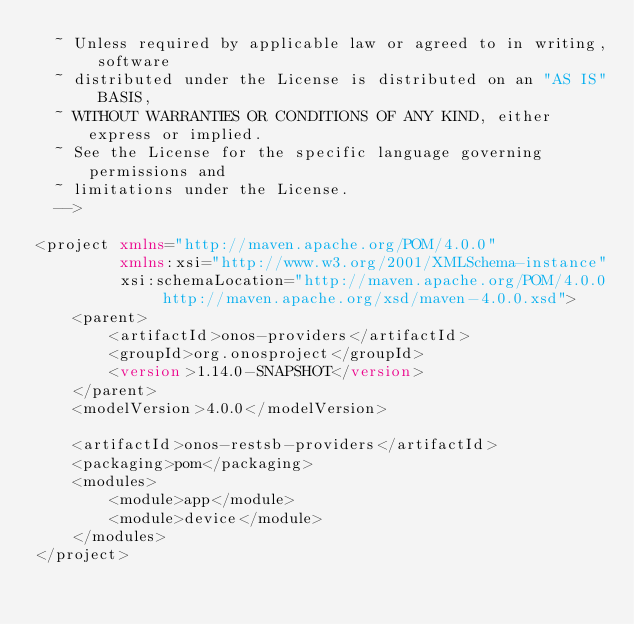<code> <loc_0><loc_0><loc_500><loc_500><_XML_>  ~ Unless required by applicable law or agreed to in writing, software
  ~ distributed under the License is distributed on an "AS IS" BASIS,
  ~ WITHOUT WARRANTIES OR CONDITIONS OF ANY KIND, either express or implied.
  ~ See the License for the specific language governing permissions and
  ~ limitations under the License.
  -->

<project xmlns="http://maven.apache.org/POM/4.0.0"
         xmlns:xsi="http://www.w3.org/2001/XMLSchema-instance"
         xsi:schemaLocation="http://maven.apache.org/POM/4.0.0 http://maven.apache.org/xsd/maven-4.0.0.xsd">
    <parent>
        <artifactId>onos-providers</artifactId>
        <groupId>org.onosproject</groupId>
        <version>1.14.0-SNAPSHOT</version>
    </parent>
    <modelVersion>4.0.0</modelVersion>

    <artifactId>onos-restsb-providers</artifactId>
    <packaging>pom</packaging>
    <modules>
        <module>app</module>
        <module>device</module>
    </modules>
</project></code> 